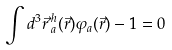Convert formula to latex. <formula><loc_0><loc_0><loc_500><loc_500>\int d ^ { 3 } \vec { r } \, ^ { h } _ { a } ( \vec { r } ) \varphi _ { a } ( \vec { r } ) - 1 = 0</formula> 